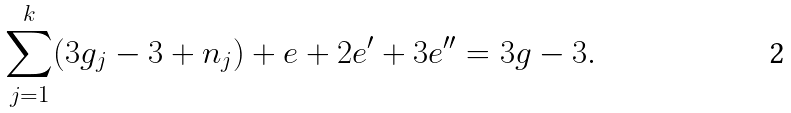<formula> <loc_0><loc_0><loc_500><loc_500>\sum _ { j = 1 } ^ { k } ( 3 g _ { j } - 3 + n _ { j } ) + e + 2 e ^ { \prime } + 3 e ^ { \prime \prime } = 3 g - 3 .</formula> 